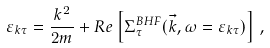Convert formula to latex. <formula><loc_0><loc_0><loc_500><loc_500>\varepsilon _ { k \tau } = \frac { k ^ { 2 } } { 2 m } + R e \left [ \Sigma ^ { B H F } _ { \tau } ( \vec { k } , \omega = \varepsilon _ { k \tau } ) \right ] \, ,</formula> 